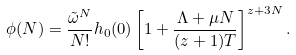<formula> <loc_0><loc_0><loc_500><loc_500>\phi ( N ) = \frac { \tilde { \omega } ^ { N } } { N ! } h _ { 0 } ( 0 ) \left [ 1 + \frac { \Lambda + \mu N } { ( z + 1 ) T } \right ] ^ { z + 3 N } .</formula> 